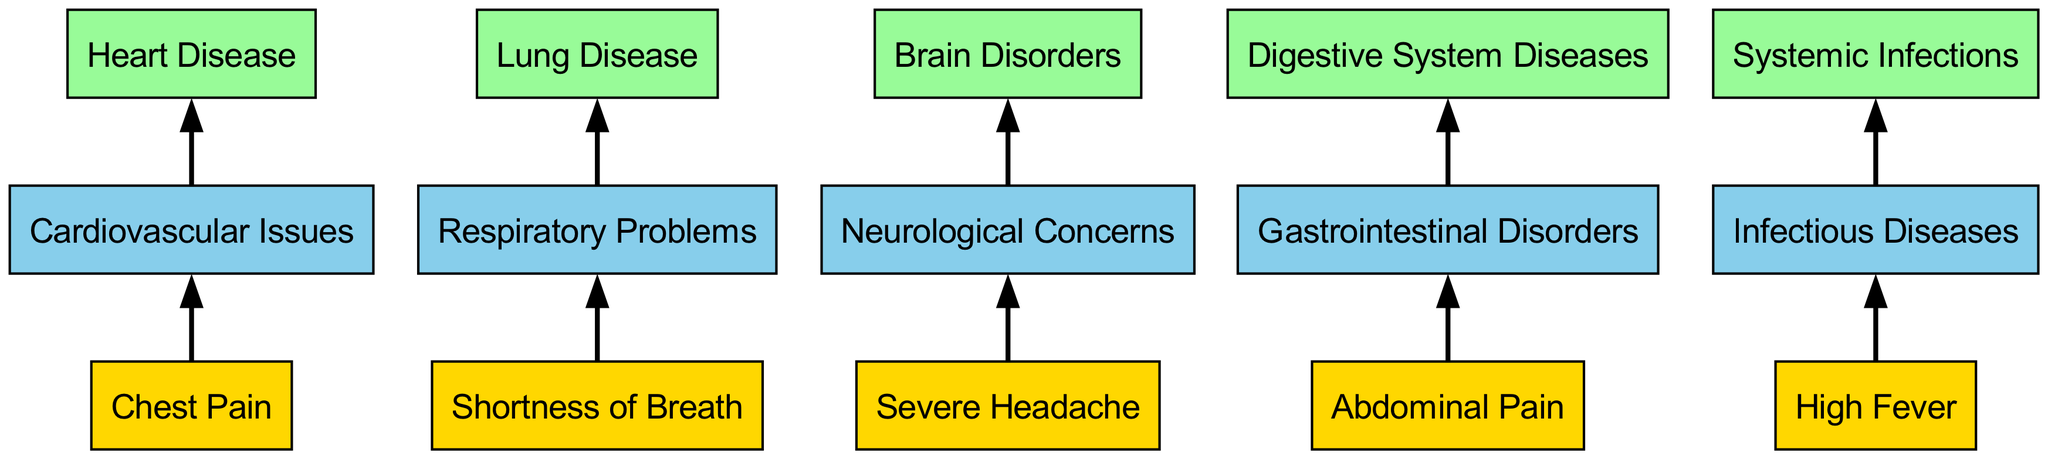What is the first symptom listed in the diagram? The first node under "Specific Symptoms" is "Chest Pain", which is located at the top of the flow chart.
Answer: Chest Pain Which intermediate category does "Abdominal Pain" connect to? "Abdominal Pain" is directly linked to the intermediate category "Gastrointestinal Disorders" in the diagram.
Answer: Gastrointestinal Disorders How many specific symptoms are illustrated in the diagram? The "Specific Symptoms" section contains a total of 5 symptoms, as identified at the top of the chart.
Answer: 5 Which broad disease category is associated with "High Fever"? From the diagram, "High Fever" connects to the intermediate category "Infectious Diseases", and that links to the broad disease category "Systemic Infections".
Answer: Systemic Infections What type of issues does "Shortness of Breath" relate to? The flow chart indicates that "Shortness of Breath" is connected to "Respiratory Problems", showing its categorization within respiratory-related concerns.
Answer: Respiratory Problems Which specific symptom leads to "Brain Disorders"? The flow chart shows that "Severe Headache" is the specific symptom that leads to the intermediate category "Neurological Concerns", which then links to "Brain Disorders".
Answer: Severe Headache How many connections are present in the diagram? By counting the arrows (edges) that indicate connections between nodes, we find that there are 10 distinct connections.
Answer: 10 What is the final broad disease category listed in the diagram? The last node in the "Broad Disease Categories" section is "Systemic Infections", which appears at the bottom of the flow chart.
Answer: Systemic Infections Which symptom is related to "Heart Disease"? The diagram shows that "Chest Pain" connects to the intermediate category "Cardiovascular Issues", which in turn leads to "Heart Disease".
Answer: Chest Pain 